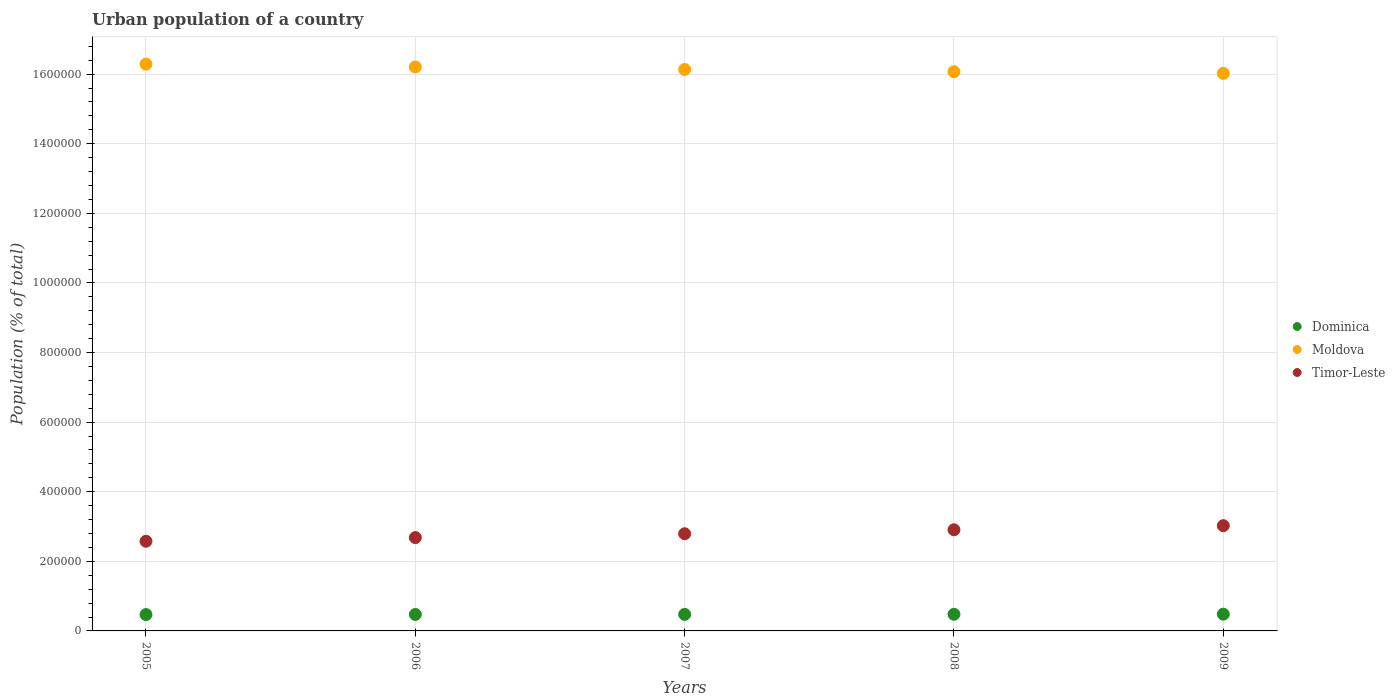How many different coloured dotlines are there?
Keep it short and to the point. 3. Is the number of dotlines equal to the number of legend labels?
Provide a short and direct response. Yes. What is the urban population in Moldova in 2006?
Your answer should be very brief. 1.62e+06. Across all years, what is the maximum urban population in Timor-Leste?
Provide a short and direct response. 3.02e+05. Across all years, what is the minimum urban population in Dominica?
Make the answer very short. 4.70e+04. In which year was the urban population in Dominica minimum?
Make the answer very short. 2005. What is the total urban population in Timor-Leste in the graph?
Offer a terse response. 1.40e+06. What is the difference between the urban population in Moldova in 2006 and that in 2008?
Give a very brief answer. 1.39e+04. What is the difference between the urban population in Dominica in 2005 and the urban population in Moldova in 2007?
Keep it short and to the point. -1.57e+06. What is the average urban population in Moldova per year?
Your answer should be very brief. 1.61e+06. In the year 2008, what is the difference between the urban population in Timor-Leste and urban population in Dominica?
Provide a succinct answer. 2.43e+05. What is the ratio of the urban population in Dominica in 2007 to that in 2009?
Give a very brief answer. 0.99. Is the urban population in Timor-Leste in 2008 less than that in 2009?
Offer a terse response. Yes. What is the difference between the highest and the second highest urban population in Timor-Leste?
Your answer should be very brief. 1.18e+04. What is the difference between the highest and the lowest urban population in Timor-Leste?
Ensure brevity in your answer.  4.48e+04. In how many years, is the urban population in Moldova greater than the average urban population in Moldova taken over all years?
Ensure brevity in your answer.  2. Is the sum of the urban population in Dominica in 2005 and 2007 greater than the maximum urban population in Timor-Leste across all years?
Ensure brevity in your answer.  No. Is the urban population in Timor-Leste strictly greater than the urban population in Moldova over the years?
Provide a short and direct response. No. Is the urban population in Moldova strictly less than the urban population in Timor-Leste over the years?
Your response must be concise. No. How many dotlines are there?
Ensure brevity in your answer.  3. How many years are there in the graph?
Your response must be concise. 5. Does the graph contain any zero values?
Provide a succinct answer. No. How many legend labels are there?
Offer a terse response. 3. What is the title of the graph?
Make the answer very short. Urban population of a country. Does "Sub-Saharan Africa (all income levels)" appear as one of the legend labels in the graph?
Provide a short and direct response. No. What is the label or title of the Y-axis?
Provide a short and direct response. Population (% of total). What is the Population (% of total) in Dominica in 2005?
Ensure brevity in your answer.  4.70e+04. What is the Population (% of total) in Moldova in 2005?
Your answer should be very brief. 1.63e+06. What is the Population (% of total) in Timor-Leste in 2005?
Offer a very short reply. 2.58e+05. What is the Population (% of total) in Dominica in 2006?
Offer a very short reply. 4.73e+04. What is the Population (% of total) of Moldova in 2006?
Your answer should be compact. 1.62e+06. What is the Population (% of total) in Timor-Leste in 2006?
Give a very brief answer. 2.68e+05. What is the Population (% of total) of Dominica in 2007?
Your answer should be compact. 4.76e+04. What is the Population (% of total) in Moldova in 2007?
Keep it short and to the point. 1.61e+06. What is the Population (% of total) in Timor-Leste in 2007?
Keep it short and to the point. 2.79e+05. What is the Population (% of total) of Dominica in 2008?
Give a very brief answer. 4.78e+04. What is the Population (% of total) of Moldova in 2008?
Provide a succinct answer. 1.61e+06. What is the Population (% of total) in Timor-Leste in 2008?
Keep it short and to the point. 2.91e+05. What is the Population (% of total) of Dominica in 2009?
Your answer should be very brief. 4.81e+04. What is the Population (% of total) of Moldova in 2009?
Your response must be concise. 1.60e+06. What is the Population (% of total) in Timor-Leste in 2009?
Give a very brief answer. 3.02e+05. Across all years, what is the maximum Population (% of total) in Dominica?
Offer a terse response. 4.81e+04. Across all years, what is the maximum Population (% of total) of Moldova?
Make the answer very short. 1.63e+06. Across all years, what is the maximum Population (% of total) in Timor-Leste?
Give a very brief answer. 3.02e+05. Across all years, what is the minimum Population (% of total) in Dominica?
Ensure brevity in your answer.  4.70e+04. Across all years, what is the minimum Population (% of total) in Moldova?
Offer a terse response. 1.60e+06. Across all years, what is the minimum Population (% of total) of Timor-Leste?
Your answer should be very brief. 2.58e+05. What is the total Population (% of total) of Dominica in the graph?
Make the answer very short. 2.38e+05. What is the total Population (% of total) of Moldova in the graph?
Give a very brief answer. 8.07e+06. What is the total Population (% of total) of Timor-Leste in the graph?
Your response must be concise. 1.40e+06. What is the difference between the Population (% of total) in Dominica in 2005 and that in 2006?
Give a very brief answer. -312. What is the difference between the Population (% of total) of Moldova in 2005 and that in 2006?
Make the answer very short. 8070. What is the difference between the Population (% of total) of Timor-Leste in 2005 and that in 2006?
Ensure brevity in your answer.  -1.06e+04. What is the difference between the Population (% of total) in Dominica in 2005 and that in 2007?
Keep it short and to the point. -594. What is the difference between the Population (% of total) in Moldova in 2005 and that in 2007?
Provide a succinct answer. 1.54e+04. What is the difference between the Population (% of total) in Timor-Leste in 2005 and that in 2007?
Provide a short and direct response. -2.16e+04. What is the difference between the Population (% of total) of Dominica in 2005 and that in 2008?
Keep it short and to the point. -864. What is the difference between the Population (% of total) in Moldova in 2005 and that in 2008?
Offer a very short reply. 2.20e+04. What is the difference between the Population (% of total) in Timor-Leste in 2005 and that in 2008?
Provide a short and direct response. -3.30e+04. What is the difference between the Population (% of total) in Dominica in 2005 and that in 2009?
Your response must be concise. -1152. What is the difference between the Population (% of total) in Moldova in 2005 and that in 2009?
Your response must be concise. 2.67e+04. What is the difference between the Population (% of total) in Timor-Leste in 2005 and that in 2009?
Keep it short and to the point. -4.48e+04. What is the difference between the Population (% of total) of Dominica in 2006 and that in 2007?
Offer a very short reply. -282. What is the difference between the Population (% of total) of Moldova in 2006 and that in 2007?
Your answer should be very brief. 7293. What is the difference between the Population (% of total) in Timor-Leste in 2006 and that in 2007?
Give a very brief answer. -1.10e+04. What is the difference between the Population (% of total) in Dominica in 2006 and that in 2008?
Ensure brevity in your answer.  -552. What is the difference between the Population (% of total) of Moldova in 2006 and that in 2008?
Give a very brief answer. 1.39e+04. What is the difference between the Population (% of total) of Timor-Leste in 2006 and that in 2008?
Keep it short and to the point. -2.24e+04. What is the difference between the Population (% of total) of Dominica in 2006 and that in 2009?
Offer a terse response. -840. What is the difference between the Population (% of total) in Moldova in 2006 and that in 2009?
Offer a very short reply. 1.86e+04. What is the difference between the Population (% of total) in Timor-Leste in 2006 and that in 2009?
Give a very brief answer. -3.42e+04. What is the difference between the Population (% of total) in Dominica in 2007 and that in 2008?
Your answer should be very brief. -270. What is the difference between the Population (% of total) of Moldova in 2007 and that in 2008?
Offer a terse response. 6603. What is the difference between the Population (% of total) of Timor-Leste in 2007 and that in 2008?
Give a very brief answer. -1.14e+04. What is the difference between the Population (% of total) of Dominica in 2007 and that in 2009?
Provide a succinct answer. -558. What is the difference between the Population (% of total) of Moldova in 2007 and that in 2009?
Keep it short and to the point. 1.13e+04. What is the difference between the Population (% of total) of Timor-Leste in 2007 and that in 2009?
Offer a very short reply. -2.32e+04. What is the difference between the Population (% of total) in Dominica in 2008 and that in 2009?
Provide a short and direct response. -288. What is the difference between the Population (% of total) in Moldova in 2008 and that in 2009?
Your answer should be compact. 4701. What is the difference between the Population (% of total) of Timor-Leste in 2008 and that in 2009?
Offer a very short reply. -1.18e+04. What is the difference between the Population (% of total) of Dominica in 2005 and the Population (% of total) of Moldova in 2006?
Provide a short and direct response. -1.57e+06. What is the difference between the Population (% of total) in Dominica in 2005 and the Population (% of total) in Timor-Leste in 2006?
Offer a terse response. -2.21e+05. What is the difference between the Population (% of total) in Moldova in 2005 and the Population (% of total) in Timor-Leste in 2006?
Offer a terse response. 1.36e+06. What is the difference between the Population (% of total) in Dominica in 2005 and the Population (% of total) in Moldova in 2007?
Your answer should be compact. -1.57e+06. What is the difference between the Population (% of total) of Dominica in 2005 and the Population (% of total) of Timor-Leste in 2007?
Your answer should be very brief. -2.32e+05. What is the difference between the Population (% of total) of Moldova in 2005 and the Population (% of total) of Timor-Leste in 2007?
Give a very brief answer. 1.35e+06. What is the difference between the Population (% of total) in Dominica in 2005 and the Population (% of total) in Moldova in 2008?
Keep it short and to the point. -1.56e+06. What is the difference between the Population (% of total) of Dominica in 2005 and the Population (% of total) of Timor-Leste in 2008?
Your answer should be very brief. -2.44e+05. What is the difference between the Population (% of total) of Moldova in 2005 and the Population (% of total) of Timor-Leste in 2008?
Keep it short and to the point. 1.34e+06. What is the difference between the Population (% of total) in Dominica in 2005 and the Population (% of total) in Moldova in 2009?
Offer a terse response. -1.56e+06. What is the difference between the Population (% of total) in Dominica in 2005 and the Population (% of total) in Timor-Leste in 2009?
Give a very brief answer. -2.55e+05. What is the difference between the Population (% of total) of Moldova in 2005 and the Population (% of total) of Timor-Leste in 2009?
Offer a very short reply. 1.33e+06. What is the difference between the Population (% of total) in Dominica in 2006 and the Population (% of total) in Moldova in 2007?
Ensure brevity in your answer.  -1.57e+06. What is the difference between the Population (% of total) of Dominica in 2006 and the Population (% of total) of Timor-Leste in 2007?
Provide a short and direct response. -2.32e+05. What is the difference between the Population (% of total) in Moldova in 2006 and the Population (% of total) in Timor-Leste in 2007?
Provide a succinct answer. 1.34e+06. What is the difference between the Population (% of total) of Dominica in 2006 and the Population (% of total) of Moldova in 2008?
Your answer should be compact. -1.56e+06. What is the difference between the Population (% of total) of Dominica in 2006 and the Population (% of total) of Timor-Leste in 2008?
Your answer should be very brief. -2.43e+05. What is the difference between the Population (% of total) in Moldova in 2006 and the Population (% of total) in Timor-Leste in 2008?
Provide a succinct answer. 1.33e+06. What is the difference between the Population (% of total) in Dominica in 2006 and the Population (% of total) in Moldova in 2009?
Your response must be concise. -1.55e+06. What is the difference between the Population (% of total) in Dominica in 2006 and the Population (% of total) in Timor-Leste in 2009?
Your answer should be very brief. -2.55e+05. What is the difference between the Population (% of total) of Moldova in 2006 and the Population (% of total) of Timor-Leste in 2009?
Your answer should be very brief. 1.32e+06. What is the difference between the Population (% of total) of Dominica in 2007 and the Population (% of total) of Moldova in 2008?
Your answer should be very brief. -1.56e+06. What is the difference between the Population (% of total) in Dominica in 2007 and the Population (% of total) in Timor-Leste in 2008?
Offer a terse response. -2.43e+05. What is the difference between the Population (% of total) in Moldova in 2007 and the Population (% of total) in Timor-Leste in 2008?
Provide a succinct answer. 1.32e+06. What is the difference between the Population (% of total) of Dominica in 2007 and the Population (% of total) of Moldova in 2009?
Your answer should be very brief. -1.55e+06. What is the difference between the Population (% of total) of Dominica in 2007 and the Population (% of total) of Timor-Leste in 2009?
Your answer should be very brief. -2.55e+05. What is the difference between the Population (% of total) of Moldova in 2007 and the Population (% of total) of Timor-Leste in 2009?
Your response must be concise. 1.31e+06. What is the difference between the Population (% of total) of Dominica in 2008 and the Population (% of total) of Moldova in 2009?
Ensure brevity in your answer.  -1.55e+06. What is the difference between the Population (% of total) of Dominica in 2008 and the Population (% of total) of Timor-Leste in 2009?
Provide a succinct answer. -2.55e+05. What is the difference between the Population (% of total) in Moldova in 2008 and the Population (% of total) in Timor-Leste in 2009?
Make the answer very short. 1.30e+06. What is the average Population (% of total) of Dominica per year?
Your answer should be very brief. 4.76e+04. What is the average Population (% of total) of Moldova per year?
Give a very brief answer. 1.61e+06. What is the average Population (% of total) in Timor-Leste per year?
Provide a short and direct response. 2.80e+05. In the year 2005, what is the difference between the Population (% of total) in Dominica and Population (% of total) in Moldova?
Your answer should be compact. -1.58e+06. In the year 2005, what is the difference between the Population (% of total) in Dominica and Population (% of total) in Timor-Leste?
Keep it short and to the point. -2.11e+05. In the year 2005, what is the difference between the Population (% of total) of Moldova and Population (% of total) of Timor-Leste?
Your answer should be very brief. 1.37e+06. In the year 2006, what is the difference between the Population (% of total) in Dominica and Population (% of total) in Moldova?
Provide a short and direct response. -1.57e+06. In the year 2006, what is the difference between the Population (% of total) of Dominica and Population (% of total) of Timor-Leste?
Keep it short and to the point. -2.21e+05. In the year 2006, what is the difference between the Population (% of total) in Moldova and Population (% of total) in Timor-Leste?
Offer a very short reply. 1.35e+06. In the year 2007, what is the difference between the Population (% of total) of Dominica and Population (% of total) of Moldova?
Offer a terse response. -1.57e+06. In the year 2007, what is the difference between the Population (% of total) in Dominica and Population (% of total) in Timor-Leste?
Offer a terse response. -2.32e+05. In the year 2007, what is the difference between the Population (% of total) in Moldova and Population (% of total) in Timor-Leste?
Your answer should be very brief. 1.33e+06. In the year 2008, what is the difference between the Population (% of total) in Dominica and Population (% of total) in Moldova?
Offer a very short reply. -1.56e+06. In the year 2008, what is the difference between the Population (% of total) of Dominica and Population (% of total) of Timor-Leste?
Provide a short and direct response. -2.43e+05. In the year 2008, what is the difference between the Population (% of total) in Moldova and Population (% of total) in Timor-Leste?
Keep it short and to the point. 1.32e+06. In the year 2009, what is the difference between the Population (% of total) of Dominica and Population (% of total) of Moldova?
Keep it short and to the point. -1.55e+06. In the year 2009, what is the difference between the Population (% of total) of Dominica and Population (% of total) of Timor-Leste?
Your response must be concise. -2.54e+05. In the year 2009, what is the difference between the Population (% of total) of Moldova and Population (% of total) of Timor-Leste?
Your response must be concise. 1.30e+06. What is the ratio of the Population (% of total) in Timor-Leste in 2005 to that in 2006?
Ensure brevity in your answer.  0.96. What is the ratio of the Population (% of total) of Dominica in 2005 to that in 2007?
Make the answer very short. 0.99. What is the ratio of the Population (% of total) in Moldova in 2005 to that in 2007?
Your response must be concise. 1.01. What is the ratio of the Population (% of total) of Timor-Leste in 2005 to that in 2007?
Your response must be concise. 0.92. What is the ratio of the Population (% of total) of Dominica in 2005 to that in 2008?
Offer a terse response. 0.98. What is the ratio of the Population (% of total) in Moldova in 2005 to that in 2008?
Keep it short and to the point. 1.01. What is the ratio of the Population (% of total) of Timor-Leste in 2005 to that in 2008?
Offer a very short reply. 0.89. What is the ratio of the Population (% of total) of Dominica in 2005 to that in 2009?
Your answer should be very brief. 0.98. What is the ratio of the Population (% of total) of Moldova in 2005 to that in 2009?
Your answer should be very brief. 1.02. What is the ratio of the Population (% of total) of Timor-Leste in 2005 to that in 2009?
Keep it short and to the point. 0.85. What is the ratio of the Population (% of total) of Timor-Leste in 2006 to that in 2007?
Your response must be concise. 0.96. What is the ratio of the Population (% of total) in Moldova in 2006 to that in 2008?
Provide a short and direct response. 1.01. What is the ratio of the Population (% of total) in Timor-Leste in 2006 to that in 2008?
Your response must be concise. 0.92. What is the ratio of the Population (% of total) in Dominica in 2006 to that in 2009?
Ensure brevity in your answer.  0.98. What is the ratio of the Population (% of total) in Moldova in 2006 to that in 2009?
Provide a succinct answer. 1.01. What is the ratio of the Population (% of total) of Timor-Leste in 2006 to that in 2009?
Give a very brief answer. 0.89. What is the ratio of the Population (% of total) in Moldova in 2007 to that in 2008?
Your response must be concise. 1. What is the ratio of the Population (% of total) of Timor-Leste in 2007 to that in 2008?
Provide a succinct answer. 0.96. What is the ratio of the Population (% of total) in Dominica in 2007 to that in 2009?
Give a very brief answer. 0.99. What is the ratio of the Population (% of total) of Moldova in 2007 to that in 2009?
Your answer should be very brief. 1.01. What is the ratio of the Population (% of total) in Timor-Leste in 2007 to that in 2009?
Provide a succinct answer. 0.92. What is the ratio of the Population (% of total) of Timor-Leste in 2008 to that in 2009?
Offer a terse response. 0.96. What is the difference between the highest and the second highest Population (% of total) in Dominica?
Give a very brief answer. 288. What is the difference between the highest and the second highest Population (% of total) of Moldova?
Your answer should be compact. 8070. What is the difference between the highest and the second highest Population (% of total) in Timor-Leste?
Provide a succinct answer. 1.18e+04. What is the difference between the highest and the lowest Population (% of total) of Dominica?
Ensure brevity in your answer.  1152. What is the difference between the highest and the lowest Population (% of total) in Moldova?
Your answer should be compact. 2.67e+04. What is the difference between the highest and the lowest Population (% of total) in Timor-Leste?
Provide a succinct answer. 4.48e+04. 